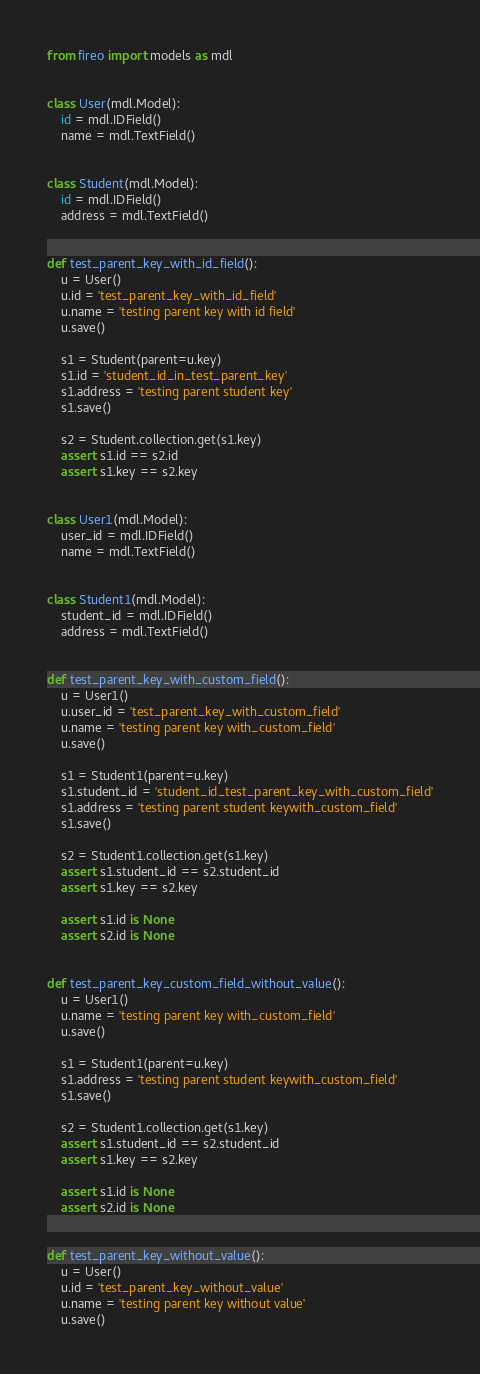<code> <loc_0><loc_0><loc_500><loc_500><_Python_>from fireo import models as mdl


class User(mdl.Model):
    id = mdl.IDField()
    name = mdl.TextField()


class Student(mdl.Model):
    id = mdl.IDField()
    address = mdl.TextField()


def test_parent_key_with_id_field():
    u = User()
    u.id = 'test_parent_key_with_id_field'
    u.name = 'testing parent key with id field'
    u.save()

    s1 = Student(parent=u.key)
    s1.id = 'student_id_in_test_parent_key'
    s1.address = 'testing parent student key'
    s1.save()

    s2 = Student.collection.get(s1.key)
    assert s1.id == s2.id
    assert s1.key == s2.key


class User1(mdl.Model):
    user_id = mdl.IDField()
    name = mdl.TextField()


class Student1(mdl.Model):
    student_id = mdl.IDField()
    address = mdl.TextField()


def test_parent_key_with_custom_field():
    u = User1()
    u.user_id = 'test_parent_key_with_custom_field'
    u.name = 'testing parent key with_custom_field'
    u.save()

    s1 = Student1(parent=u.key)
    s1.student_id = 'student_id_test_parent_key_with_custom_field'
    s1.address = 'testing parent student keywith_custom_field'
    s1.save()

    s2 = Student1.collection.get(s1.key)
    assert s1.student_id == s2.student_id
    assert s1.key == s2.key

    assert s1.id is None
    assert s2.id is None


def test_parent_key_custom_field_without_value():
    u = User1()
    u.name = 'testing parent key with_custom_field'
    u.save()

    s1 = Student1(parent=u.key)
    s1.address = 'testing parent student keywith_custom_field'
    s1.save()

    s2 = Student1.collection.get(s1.key)
    assert s1.student_id == s2.student_id
    assert s1.key == s2.key

    assert s1.id is None
    assert s2.id is None


def test_parent_key_without_value():
    u = User()
    u.id = 'test_parent_key_without_value'
    u.name = 'testing parent key without value'
    u.save()
</code> 